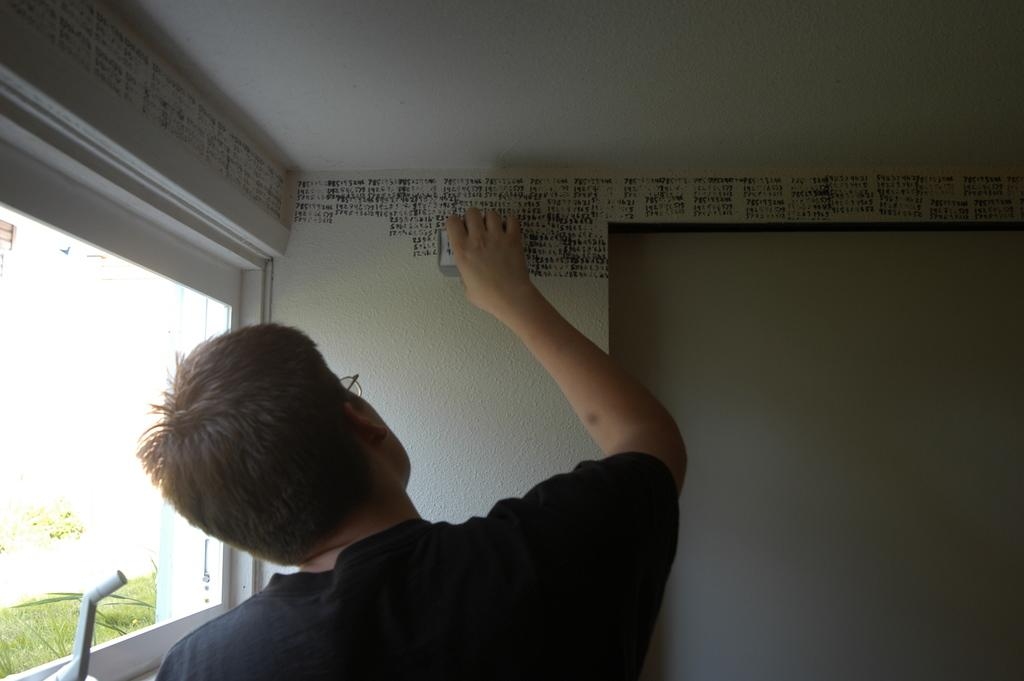What is the man in the image doing? The man is painting on a wall. Can you describe the location of the window in the image? The window is on the left side of the image. What is visible in the background of the image? There is a wall visible in the background of the image. What type of dirt can be seen in the field behind the man? There is no field or dirt present in the image; it features a man painting on a wall with a window on the left side and a wall visible in the background. 